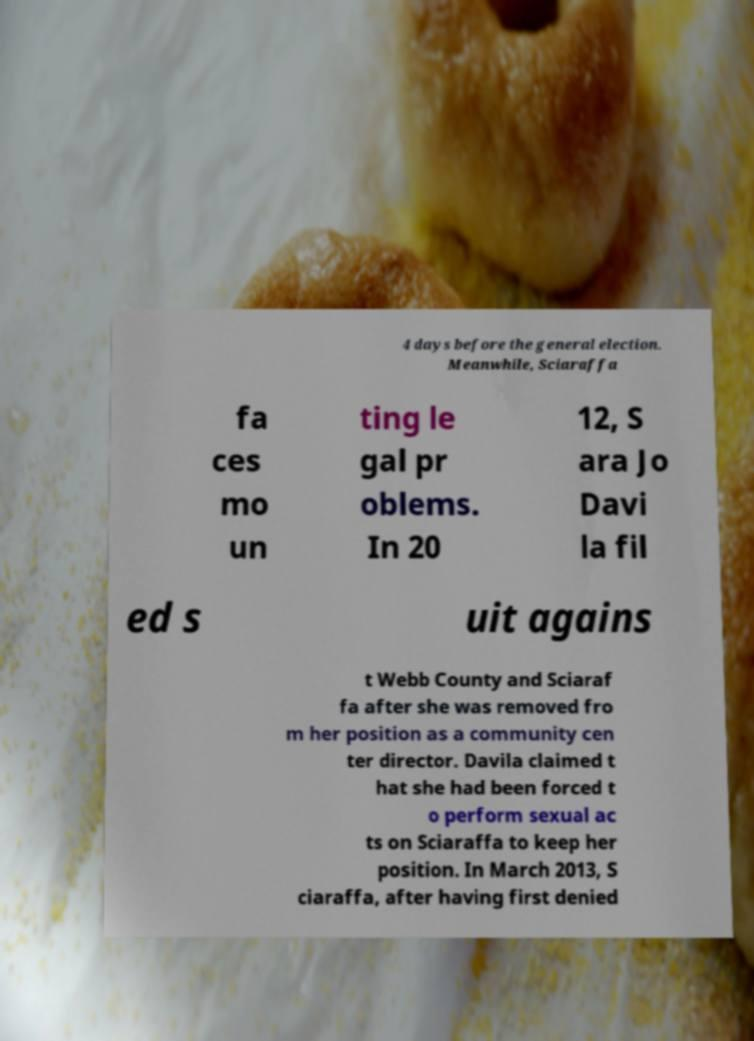Please read and relay the text visible in this image. What does it say? 4 days before the general election. Meanwhile, Sciaraffa fa ces mo un ting le gal pr oblems. In 20 12, S ara Jo Davi la fil ed s uit agains t Webb County and Sciaraf fa after she was removed fro m her position as a community cen ter director. Davila claimed t hat she had been forced t o perform sexual ac ts on Sciaraffa to keep her position. In March 2013, S ciaraffa, after having first denied 